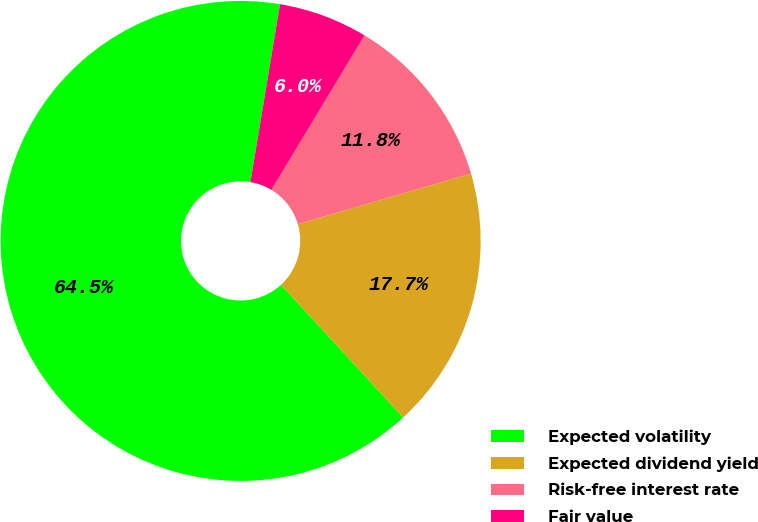Convert chart to OTSL. <chart><loc_0><loc_0><loc_500><loc_500><pie_chart><fcel>Expected volatility<fcel>Expected dividend yield<fcel>Risk-free interest rate<fcel>Fair value<nl><fcel>64.47%<fcel>17.68%<fcel>11.84%<fcel>6.01%<nl></chart> 